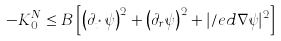<formula> <loc_0><loc_0><loc_500><loc_500>- K ^ { N } _ { 0 } \leq B \left [ \left ( \partial _ { t ^ { ^ { * } } } \psi \right ) ^ { 2 } + \left ( \partial _ { r } \psi \right ) ^ { 2 } + | \slash e d { \nabla } \psi | ^ { 2 } \right ]</formula> 